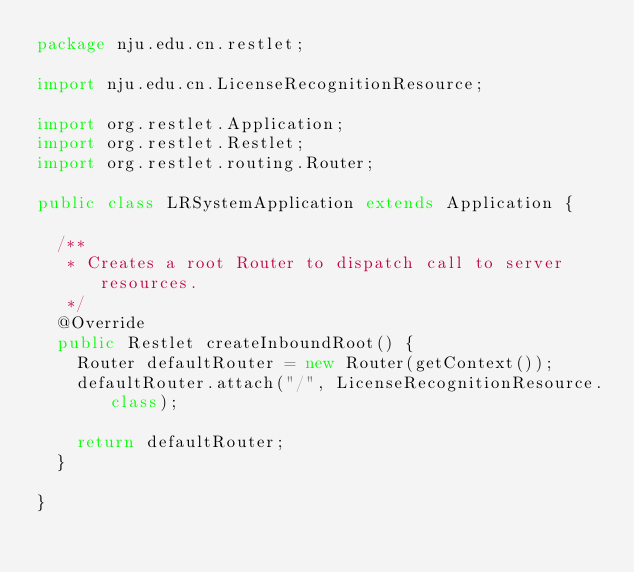Convert code to text. <code><loc_0><loc_0><loc_500><loc_500><_Java_>package nju.edu.cn.restlet;

import nju.edu.cn.LicenseRecognitionResource;

import org.restlet.Application;
import org.restlet.Restlet;
import org.restlet.routing.Router;

public class LRSystemApplication extends Application {

	/**
	 * Creates a root Router to dispatch call to server resources.
	 */
	@Override
	public Restlet createInboundRoot() {
		Router defaultRouter = new Router(getContext());
		defaultRouter.attach("/", LicenseRecognitionResource.class);

		return defaultRouter;
	}

}</code> 